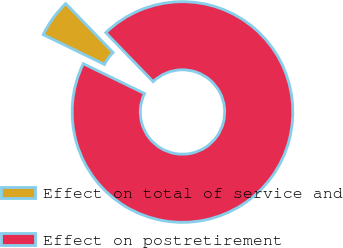Convert chart. <chart><loc_0><loc_0><loc_500><loc_500><pie_chart><fcel>Effect on total of service and<fcel>Effect on postretirement<nl><fcel>5.56%<fcel>94.44%<nl></chart> 